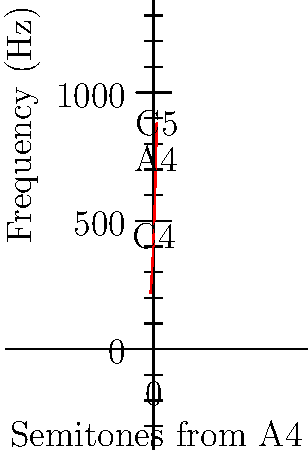In Oh My Girl's song "Nonstop", the main melody starts with a C4 note. If A4 has a frequency of 440 Hz, what is the frequency of the C5 note, which is often used in the chorus? (Round your answer to the nearest whole number.) To solve this problem, we'll use the relationship between musical notes and their frequencies:

1) First, we need to understand that C5 is 12 semitones above C4, and A4 is 9 semitones above C4.

2) The frequency ratio between two adjacent semitones is the 12th root of 2 (approximately 1.0595).

3) We can use the formula: $f = 440 \times 2^{n/12}$, where $n$ is the number of semitones from A4.

4) C5 is 3 semitones above A4, so $n = 3$.

5) Plugging this into our formula:
   $f = 440 \times 2^{3/12}$

6) Calculate:
   $f = 440 \times 2^{0.25}$
   $f = 440 \times 1.1892$
   $f = 523.2511$

7) Rounding to the nearest whole number: 523 Hz
Answer: 523 Hz 